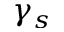<formula> <loc_0><loc_0><loc_500><loc_500>\gamma _ { s }</formula> 